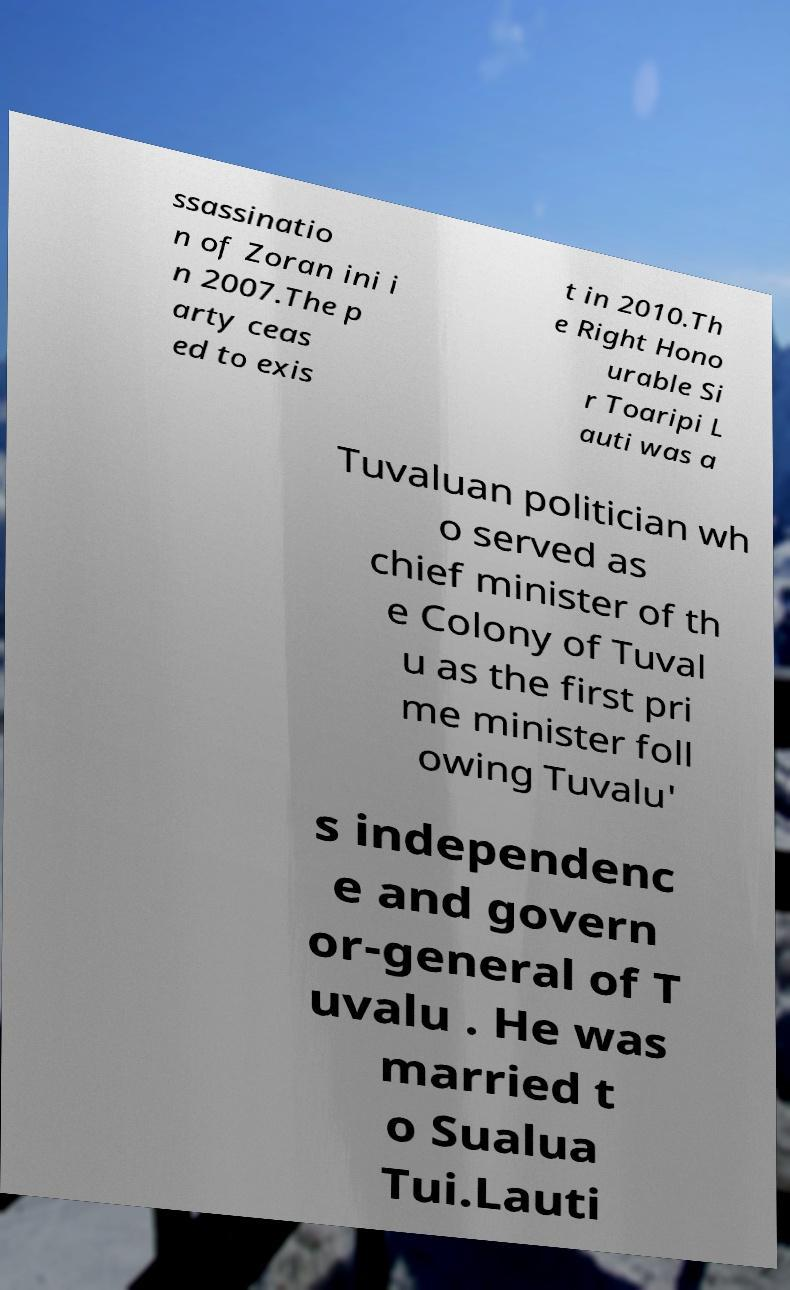Can you read and provide the text displayed in the image?This photo seems to have some interesting text. Can you extract and type it out for me? ssassinatio n of Zoran ini i n 2007.The p arty ceas ed to exis t in 2010.Th e Right Hono urable Si r Toaripi L auti was a Tuvaluan politician wh o served as chief minister of th e Colony of Tuval u as the first pri me minister foll owing Tuvalu' s independenc e and govern or-general of T uvalu . He was married t o Sualua Tui.Lauti 